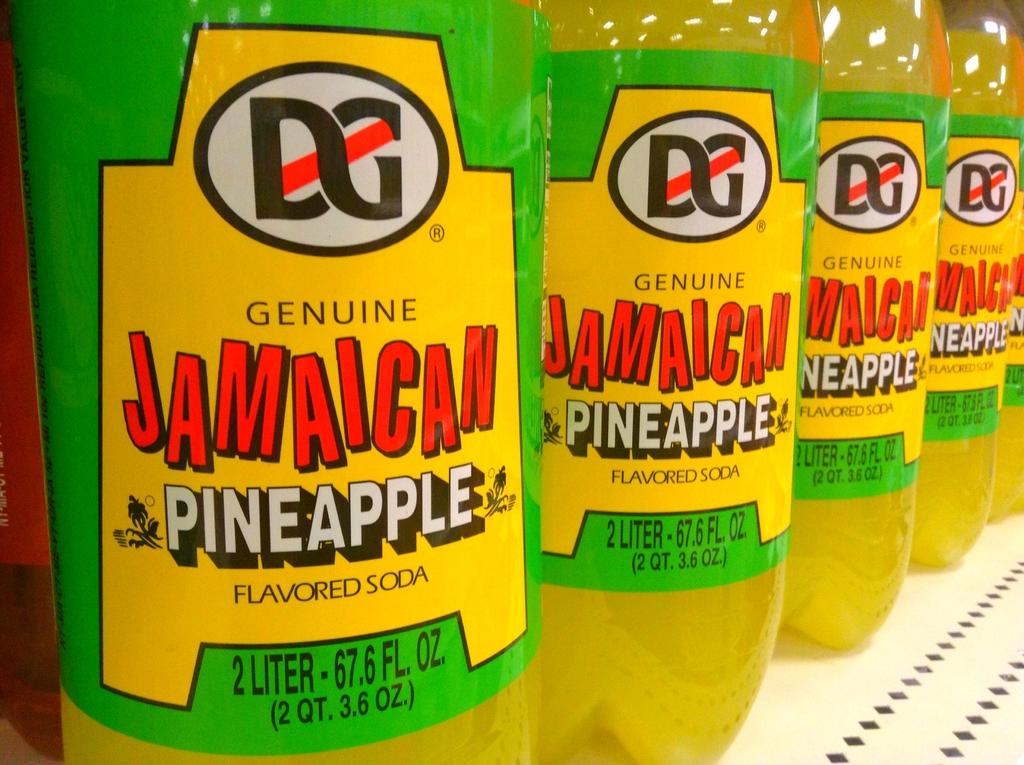How many liters are in each bottle?
Your answer should be very brief. 2. What type of drink is in the bottles?
Make the answer very short. Soda. 